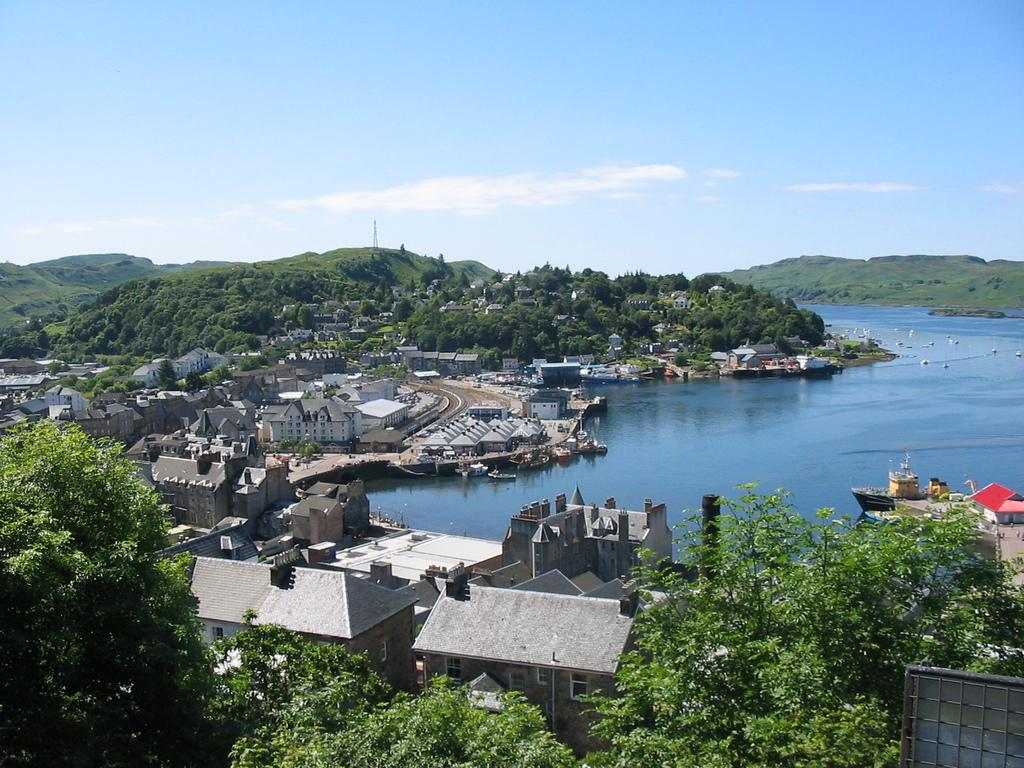What type of natural elements can be seen in the image? There are trees in the image. What type of man-made structures are present in the image? There are buildings in the image. What type of geographical feature can be seen in the image? There are hills in the image. What is located in the middle of the image? There is a water body in the middle of the image. What is the condition of the sky in the image? The sky has patches of clouds. How many spiders are crawling on the buildings in the image? There are no spiders present in the image. What type of birthday celebration is taking place in the image? There is no birthday celebration present in the image. 